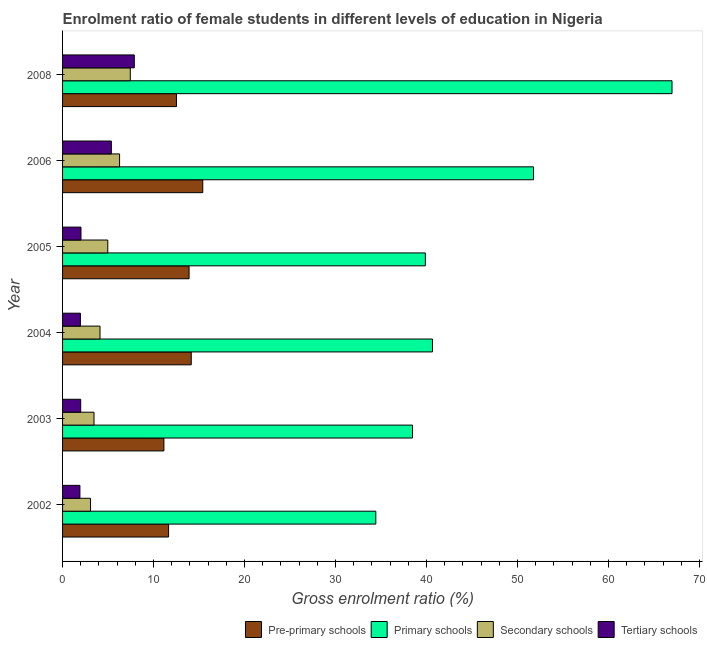Are the number of bars per tick equal to the number of legend labels?
Your response must be concise. Yes. Are the number of bars on each tick of the Y-axis equal?
Make the answer very short. Yes. How many bars are there on the 4th tick from the top?
Provide a short and direct response. 4. How many bars are there on the 6th tick from the bottom?
Ensure brevity in your answer.  4. In how many cases, is the number of bars for a given year not equal to the number of legend labels?
Your response must be concise. 0. What is the gross enrolment ratio(male) in secondary schools in 2005?
Your answer should be compact. 4.97. Across all years, what is the maximum gross enrolment ratio(male) in secondary schools?
Keep it short and to the point. 7.44. Across all years, what is the minimum gross enrolment ratio(male) in tertiary schools?
Your answer should be very brief. 1.91. In which year was the gross enrolment ratio(male) in primary schools minimum?
Give a very brief answer. 2002. What is the total gross enrolment ratio(male) in secondary schools in the graph?
Provide a succinct answer. 29.32. What is the difference between the gross enrolment ratio(male) in secondary schools in 2004 and that in 2006?
Ensure brevity in your answer.  -2.15. What is the difference between the gross enrolment ratio(male) in secondary schools in 2008 and the gross enrolment ratio(male) in primary schools in 2006?
Make the answer very short. -44.31. What is the average gross enrolment ratio(male) in tertiary schools per year?
Provide a succinct answer. 3.52. In the year 2004, what is the difference between the gross enrolment ratio(male) in primary schools and gross enrolment ratio(male) in pre-primary schools?
Offer a very short reply. 26.51. What is the ratio of the gross enrolment ratio(male) in secondary schools in 2003 to that in 2006?
Make the answer very short. 0.55. Is the gross enrolment ratio(male) in pre-primary schools in 2004 less than that in 2006?
Provide a succinct answer. Yes. What is the difference between the highest and the second highest gross enrolment ratio(male) in tertiary schools?
Your answer should be compact. 2.52. What is the difference between the highest and the lowest gross enrolment ratio(male) in secondary schools?
Make the answer very short. 4.37. What does the 3rd bar from the top in 2004 represents?
Your answer should be compact. Primary schools. What does the 2nd bar from the bottom in 2006 represents?
Give a very brief answer. Primary schools. How many bars are there?
Provide a succinct answer. 24. Are all the bars in the graph horizontal?
Keep it short and to the point. Yes. What is the difference between two consecutive major ticks on the X-axis?
Your response must be concise. 10. Are the values on the major ticks of X-axis written in scientific E-notation?
Your response must be concise. No. Does the graph contain grids?
Provide a succinct answer. No. Where does the legend appear in the graph?
Your answer should be compact. Bottom right. How many legend labels are there?
Provide a short and direct response. 4. What is the title of the graph?
Ensure brevity in your answer.  Enrolment ratio of female students in different levels of education in Nigeria. What is the label or title of the X-axis?
Your answer should be very brief. Gross enrolment ratio (%). What is the Gross enrolment ratio (%) of Pre-primary schools in 2002?
Offer a terse response. 11.65. What is the Gross enrolment ratio (%) of Primary schools in 2002?
Provide a succinct answer. 34.43. What is the Gross enrolment ratio (%) in Secondary schools in 2002?
Keep it short and to the point. 3.07. What is the Gross enrolment ratio (%) in Tertiary schools in 2002?
Provide a succinct answer. 1.91. What is the Gross enrolment ratio (%) of Pre-primary schools in 2003?
Your response must be concise. 11.14. What is the Gross enrolment ratio (%) of Primary schools in 2003?
Ensure brevity in your answer.  38.46. What is the Gross enrolment ratio (%) in Secondary schools in 2003?
Offer a very short reply. 3.46. What is the Gross enrolment ratio (%) in Tertiary schools in 2003?
Make the answer very short. 1.99. What is the Gross enrolment ratio (%) in Pre-primary schools in 2004?
Offer a terse response. 14.14. What is the Gross enrolment ratio (%) in Primary schools in 2004?
Keep it short and to the point. 40.65. What is the Gross enrolment ratio (%) of Secondary schools in 2004?
Your answer should be compact. 4.12. What is the Gross enrolment ratio (%) in Tertiary schools in 2004?
Your response must be concise. 1.96. What is the Gross enrolment ratio (%) in Pre-primary schools in 2005?
Ensure brevity in your answer.  13.9. What is the Gross enrolment ratio (%) in Primary schools in 2005?
Make the answer very short. 39.87. What is the Gross enrolment ratio (%) in Secondary schools in 2005?
Your response must be concise. 4.97. What is the Gross enrolment ratio (%) of Tertiary schools in 2005?
Provide a short and direct response. 2.02. What is the Gross enrolment ratio (%) in Pre-primary schools in 2006?
Give a very brief answer. 15.41. What is the Gross enrolment ratio (%) in Primary schools in 2006?
Ensure brevity in your answer.  51.76. What is the Gross enrolment ratio (%) in Secondary schools in 2006?
Keep it short and to the point. 6.27. What is the Gross enrolment ratio (%) in Tertiary schools in 2006?
Your response must be concise. 5.36. What is the Gross enrolment ratio (%) of Pre-primary schools in 2008?
Give a very brief answer. 12.52. What is the Gross enrolment ratio (%) in Primary schools in 2008?
Keep it short and to the point. 66.98. What is the Gross enrolment ratio (%) in Secondary schools in 2008?
Your response must be concise. 7.44. What is the Gross enrolment ratio (%) in Tertiary schools in 2008?
Provide a succinct answer. 7.88. Across all years, what is the maximum Gross enrolment ratio (%) of Pre-primary schools?
Offer a very short reply. 15.41. Across all years, what is the maximum Gross enrolment ratio (%) in Primary schools?
Give a very brief answer. 66.98. Across all years, what is the maximum Gross enrolment ratio (%) in Secondary schools?
Give a very brief answer. 7.44. Across all years, what is the maximum Gross enrolment ratio (%) in Tertiary schools?
Your response must be concise. 7.88. Across all years, what is the minimum Gross enrolment ratio (%) in Pre-primary schools?
Provide a short and direct response. 11.14. Across all years, what is the minimum Gross enrolment ratio (%) of Primary schools?
Offer a terse response. 34.43. Across all years, what is the minimum Gross enrolment ratio (%) in Secondary schools?
Provide a succinct answer. 3.07. Across all years, what is the minimum Gross enrolment ratio (%) of Tertiary schools?
Keep it short and to the point. 1.91. What is the total Gross enrolment ratio (%) of Pre-primary schools in the graph?
Make the answer very short. 78.76. What is the total Gross enrolment ratio (%) of Primary schools in the graph?
Your answer should be very brief. 272.14. What is the total Gross enrolment ratio (%) of Secondary schools in the graph?
Your answer should be very brief. 29.32. What is the total Gross enrolment ratio (%) of Tertiary schools in the graph?
Keep it short and to the point. 21.13. What is the difference between the Gross enrolment ratio (%) of Pre-primary schools in 2002 and that in 2003?
Give a very brief answer. 0.52. What is the difference between the Gross enrolment ratio (%) in Primary schools in 2002 and that in 2003?
Keep it short and to the point. -4.03. What is the difference between the Gross enrolment ratio (%) in Secondary schools in 2002 and that in 2003?
Your response must be concise. -0.38. What is the difference between the Gross enrolment ratio (%) of Tertiary schools in 2002 and that in 2003?
Give a very brief answer. -0.09. What is the difference between the Gross enrolment ratio (%) in Pre-primary schools in 2002 and that in 2004?
Offer a terse response. -2.49. What is the difference between the Gross enrolment ratio (%) of Primary schools in 2002 and that in 2004?
Offer a very short reply. -6.23. What is the difference between the Gross enrolment ratio (%) in Secondary schools in 2002 and that in 2004?
Your answer should be compact. -1.04. What is the difference between the Gross enrolment ratio (%) in Tertiary schools in 2002 and that in 2004?
Offer a terse response. -0.06. What is the difference between the Gross enrolment ratio (%) of Pre-primary schools in 2002 and that in 2005?
Your response must be concise. -2.25. What is the difference between the Gross enrolment ratio (%) of Primary schools in 2002 and that in 2005?
Your answer should be compact. -5.44. What is the difference between the Gross enrolment ratio (%) of Secondary schools in 2002 and that in 2005?
Make the answer very short. -1.89. What is the difference between the Gross enrolment ratio (%) of Tertiary schools in 2002 and that in 2005?
Provide a succinct answer. -0.12. What is the difference between the Gross enrolment ratio (%) of Pre-primary schools in 2002 and that in 2006?
Your response must be concise. -3.75. What is the difference between the Gross enrolment ratio (%) of Primary schools in 2002 and that in 2006?
Make the answer very short. -17.33. What is the difference between the Gross enrolment ratio (%) in Secondary schools in 2002 and that in 2006?
Your answer should be compact. -3.19. What is the difference between the Gross enrolment ratio (%) in Tertiary schools in 2002 and that in 2006?
Make the answer very short. -3.46. What is the difference between the Gross enrolment ratio (%) in Pre-primary schools in 2002 and that in 2008?
Your answer should be very brief. -0.87. What is the difference between the Gross enrolment ratio (%) of Primary schools in 2002 and that in 2008?
Offer a terse response. -32.55. What is the difference between the Gross enrolment ratio (%) of Secondary schools in 2002 and that in 2008?
Ensure brevity in your answer.  -4.37. What is the difference between the Gross enrolment ratio (%) in Tertiary schools in 2002 and that in 2008?
Ensure brevity in your answer.  -5.98. What is the difference between the Gross enrolment ratio (%) of Pre-primary schools in 2003 and that in 2004?
Offer a very short reply. -3.01. What is the difference between the Gross enrolment ratio (%) of Primary schools in 2003 and that in 2004?
Give a very brief answer. -2.19. What is the difference between the Gross enrolment ratio (%) in Secondary schools in 2003 and that in 2004?
Give a very brief answer. -0.66. What is the difference between the Gross enrolment ratio (%) in Tertiary schools in 2003 and that in 2004?
Keep it short and to the point. 0.03. What is the difference between the Gross enrolment ratio (%) of Pre-primary schools in 2003 and that in 2005?
Offer a very short reply. -2.77. What is the difference between the Gross enrolment ratio (%) of Primary schools in 2003 and that in 2005?
Your answer should be very brief. -1.41. What is the difference between the Gross enrolment ratio (%) of Secondary schools in 2003 and that in 2005?
Give a very brief answer. -1.51. What is the difference between the Gross enrolment ratio (%) of Tertiary schools in 2003 and that in 2005?
Your response must be concise. -0.03. What is the difference between the Gross enrolment ratio (%) in Pre-primary schools in 2003 and that in 2006?
Offer a terse response. -4.27. What is the difference between the Gross enrolment ratio (%) in Primary schools in 2003 and that in 2006?
Provide a short and direct response. -13.3. What is the difference between the Gross enrolment ratio (%) of Secondary schools in 2003 and that in 2006?
Offer a terse response. -2.81. What is the difference between the Gross enrolment ratio (%) in Tertiary schools in 2003 and that in 2006?
Offer a terse response. -3.37. What is the difference between the Gross enrolment ratio (%) in Pre-primary schools in 2003 and that in 2008?
Offer a very short reply. -1.38. What is the difference between the Gross enrolment ratio (%) in Primary schools in 2003 and that in 2008?
Offer a very short reply. -28.52. What is the difference between the Gross enrolment ratio (%) of Secondary schools in 2003 and that in 2008?
Offer a terse response. -3.99. What is the difference between the Gross enrolment ratio (%) of Tertiary schools in 2003 and that in 2008?
Provide a short and direct response. -5.89. What is the difference between the Gross enrolment ratio (%) of Pre-primary schools in 2004 and that in 2005?
Keep it short and to the point. 0.24. What is the difference between the Gross enrolment ratio (%) of Primary schools in 2004 and that in 2005?
Provide a succinct answer. 0.78. What is the difference between the Gross enrolment ratio (%) of Secondary schools in 2004 and that in 2005?
Provide a short and direct response. -0.85. What is the difference between the Gross enrolment ratio (%) of Tertiary schools in 2004 and that in 2005?
Keep it short and to the point. -0.06. What is the difference between the Gross enrolment ratio (%) in Pre-primary schools in 2004 and that in 2006?
Offer a very short reply. -1.27. What is the difference between the Gross enrolment ratio (%) of Primary schools in 2004 and that in 2006?
Keep it short and to the point. -11.1. What is the difference between the Gross enrolment ratio (%) in Secondary schools in 2004 and that in 2006?
Provide a short and direct response. -2.15. What is the difference between the Gross enrolment ratio (%) in Tertiary schools in 2004 and that in 2006?
Keep it short and to the point. -3.4. What is the difference between the Gross enrolment ratio (%) in Pre-primary schools in 2004 and that in 2008?
Ensure brevity in your answer.  1.62. What is the difference between the Gross enrolment ratio (%) of Primary schools in 2004 and that in 2008?
Provide a short and direct response. -26.33. What is the difference between the Gross enrolment ratio (%) in Secondary schools in 2004 and that in 2008?
Make the answer very short. -3.33. What is the difference between the Gross enrolment ratio (%) of Tertiary schools in 2004 and that in 2008?
Your response must be concise. -5.92. What is the difference between the Gross enrolment ratio (%) in Pre-primary schools in 2005 and that in 2006?
Ensure brevity in your answer.  -1.5. What is the difference between the Gross enrolment ratio (%) of Primary schools in 2005 and that in 2006?
Your response must be concise. -11.89. What is the difference between the Gross enrolment ratio (%) in Secondary schools in 2005 and that in 2006?
Offer a terse response. -1.3. What is the difference between the Gross enrolment ratio (%) in Tertiary schools in 2005 and that in 2006?
Give a very brief answer. -3.34. What is the difference between the Gross enrolment ratio (%) of Pre-primary schools in 2005 and that in 2008?
Ensure brevity in your answer.  1.39. What is the difference between the Gross enrolment ratio (%) in Primary schools in 2005 and that in 2008?
Provide a succinct answer. -27.11. What is the difference between the Gross enrolment ratio (%) in Secondary schools in 2005 and that in 2008?
Keep it short and to the point. -2.47. What is the difference between the Gross enrolment ratio (%) in Tertiary schools in 2005 and that in 2008?
Your answer should be compact. -5.86. What is the difference between the Gross enrolment ratio (%) of Pre-primary schools in 2006 and that in 2008?
Your answer should be compact. 2.89. What is the difference between the Gross enrolment ratio (%) in Primary schools in 2006 and that in 2008?
Your response must be concise. -15.22. What is the difference between the Gross enrolment ratio (%) of Secondary schools in 2006 and that in 2008?
Ensure brevity in your answer.  -1.18. What is the difference between the Gross enrolment ratio (%) in Tertiary schools in 2006 and that in 2008?
Give a very brief answer. -2.52. What is the difference between the Gross enrolment ratio (%) in Pre-primary schools in 2002 and the Gross enrolment ratio (%) in Primary schools in 2003?
Offer a terse response. -26.81. What is the difference between the Gross enrolment ratio (%) of Pre-primary schools in 2002 and the Gross enrolment ratio (%) of Secondary schools in 2003?
Your answer should be very brief. 8.2. What is the difference between the Gross enrolment ratio (%) in Pre-primary schools in 2002 and the Gross enrolment ratio (%) in Tertiary schools in 2003?
Offer a very short reply. 9.66. What is the difference between the Gross enrolment ratio (%) in Primary schools in 2002 and the Gross enrolment ratio (%) in Secondary schools in 2003?
Offer a terse response. 30.97. What is the difference between the Gross enrolment ratio (%) in Primary schools in 2002 and the Gross enrolment ratio (%) in Tertiary schools in 2003?
Offer a terse response. 32.43. What is the difference between the Gross enrolment ratio (%) of Secondary schools in 2002 and the Gross enrolment ratio (%) of Tertiary schools in 2003?
Your response must be concise. 1.08. What is the difference between the Gross enrolment ratio (%) of Pre-primary schools in 2002 and the Gross enrolment ratio (%) of Primary schools in 2004?
Give a very brief answer. -29. What is the difference between the Gross enrolment ratio (%) in Pre-primary schools in 2002 and the Gross enrolment ratio (%) in Secondary schools in 2004?
Offer a terse response. 7.54. What is the difference between the Gross enrolment ratio (%) in Pre-primary schools in 2002 and the Gross enrolment ratio (%) in Tertiary schools in 2004?
Provide a short and direct response. 9.69. What is the difference between the Gross enrolment ratio (%) of Primary schools in 2002 and the Gross enrolment ratio (%) of Secondary schools in 2004?
Give a very brief answer. 30.31. What is the difference between the Gross enrolment ratio (%) of Primary schools in 2002 and the Gross enrolment ratio (%) of Tertiary schools in 2004?
Offer a terse response. 32.46. What is the difference between the Gross enrolment ratio (%) in Secondary schools in 2002 and the Gross enrolment ratio (%) in Tertiary schools in 2004?
Give a very brief answer. 1.11. What is the difference between the Gross enrolment ratio (%) in Pre-primary schools in 2002 and the Gross enrolment ratio (%) in Primary schools in 2005?
Offer a very short reply. -28.22. What is the difference between the Gross enrolment ratio (%) in Pre-primary schools in 2002 and the Gross enrolment ratio (%) in Secondary schools in 2005?
Your answer should be very brief. 6.68. What is the difference between the Gross enrolment ratio (%) in Pre-primary schools in 2002 and the Gross enrolment ratio (%) in Tertiary schools in 2005?
Your answer should be very brief. 9.63. What is the difference between the Gross enrolment ratio (%) in Primary schools in 2002 and the Gross enrolment ratio (%) in Secondary schools in 2005?
Give a very brief answer. 29.46. What is the difference between the Gross enrolment ratio (%) of Primary schools in 2002 and the Gross enrolment ratio (%) of Tertiary schools in 2005?
Your response must be concise. 32.4. What is the difference between the Gross enrolment ratio (%) in Secondary schools in 2002 and the Gross enrolment ratio (%) in Tertiary schools in 2005?
Provide a short and direct response. 1.05. What is the difference between the Gross enrolment ratio (%) in Pre-primary schools in 2002 and the Gross enrolment ratio (%) in Primary schools in 2006?
Give a very brief answer. -40.1. What is the difference between the Gross enrolment ratio (%) of Pre-primary schools in 2002 and the Gross enrolment ratio (%) of Secondary schools in 2006?
Give a very brief answer. 5.39. What is the difference between the Gross enrolment ratio (%) in Pre-primary schools in 2002 and the Gross enrolment ratio (%) in Tertiary schools in 2006?
Give a very brief answer. 6.29. What is the difference between the Gross enrolment ratio (%) of Primary schools in 2002 and the Gross enrolment ratio (%) of Secondary schools in 2006?
Your answer should be very brief. 28.16. What is the difference between the Gross enrolment ratio (%) in Primary schools in 2002 and the Gross enrolment ratio (%) in Tertiary schools in 2006?
Ensure brevity in your answer.  29.06. What is the difference between the Gross enrolment ratio (%) of Secondary schools in 2002 and the Gross enrolment ratio (%) of Tertiary schools in 2006?
Ensure brevity in your answer.  -2.29. What is the difference between the Gross enrolment ratio (%) in Pre-primary schools in 2002 and the Gross enrolment ratio (%) in Primary schools in 2008?
Offer a terse response. -55.33. What is the difference between the Gross enrolment ratio (%) of Pre-primary schools in 2002 and the Gross enrolment ratio (%) of Secondary schools in 2008?
Your answer should be very brief. 4.21. What is the difference between the Gross enrolment ratio (%) in Pre-primary schools in 2002 and the Gross enrolment ratio (%) in Tertiary schools in 2008?
Your answer should be very brief. 3.77. What is the difference between the Gross enrolment ratio (%) in Primary schools in 2002 and the Gross enrolment ratio (%) in Secondary schools in 2008?
Offer a very short reply. 26.98. What is the difference between the Gross enrolment ratio (%) of Primary schools in 2002 and the Gross enrolment ratio (%) of Tertiary schools in 2008?
Your answer should be very brief. 26.54. What is the difference between the Gross enrolment ratio (%) of Secondary schools in 2002 and the Gross enrolment ratio (%) of Tertiary schools in 2008?
Make the answer very short. -4.81. What is the difference between the Gross enrolment ratio (%) of Pre-primary schools in 2003 and the Gross enrolment ratio (%) of Primary schools in 2004?
Make the answer very short. -29.52. What is the difference between the Gross enrolment ratio (%) of Pre-primary schools in 2003 and the Gross enrolment ratio (%) of Secondary schools in 2004?
Your response must be concise. 7.02. What is the difference between the Gross enrolment ratio (%) in Pre-primary schools in 2003 and the Gross enrolment ratio (%) in Tertiary schools in 2004?
Provide a short and direct response. 9.17. What is the difference between the Gross enrolment ratio (%) of Primary schools in 2003 and the Gross enrolment ratio (%) of Secondary schools in 2004?
Provide a short and direct response. 34.34. What is the difference between the Gross enrolment ratio (%) of Primary schools in 2003 and the Gross enrolment ratio (%) of Tertiary schools in 2004?
Your response must be concise. 36.5. What is the difference between the Gross enrolment ratio (%) in Secondary schools in 2003 and the Gross enrolment ratio (%) in Tertiary schools in 2004?
Make the answer very short. 1.49. What is the difference between the Gross enrolment ratio (%) in Pre-primary schools in 2003 and the Gross enrolment ratio (%) in Primary schools in 2005?
Keep it short and to the point. -28.73. What is the difference between the Gross enrolment ratio (%) in Pre-primary schools in 2003 and the Gross enrolment ratio (%) in Secondary schools in 2005?
Make the answer very short. 6.17. What is the difference between the Gross enrolment ratio (%) in Pre-primary schools in 2003 and the Gross enrolment ratio (%) in Tertiary schools in 2005?
Your answer should be very brief. 9.11. What is the difference between the Gross enrolment ratio (%) in Primary schools in 2003 and the Gross enrolment ratio (%) in Secondary schools in 2005?
Offer a terse response. 33.49. What is the difference between the Gross enrolment ratio (%) in Primary schools in 2003 and the Gross enrolment ratio (%) in Tertiary schools in 2005?
Your answer should be compact. 36.44. What is the difference between the Gross enrolment ratio (%) of Secondary schools in 2003 and the Gross enrolment ratio (%) of Tertiary schools in 2005?
Your answer should be compact. 1.43. What is the difference between the Gross enrolment ratio (%) in Pre-primary schools in 2003 and the Gross enrolment ratio (%) in Primary schools in 2006?
Keep it short and to the point. -40.62. What is the difference between the Gross enrolment ratio (%) in Pre-primary schools in 2003 and the Gross enrolment ratio (%) in Secondary schools in 2006?
Make the answer very short. 4.87. What is the difference between the Gross enrolment ratio (%) in Pre-primary schools in 2003 and the Gross enrolment ratio (%) in Tertiary schools in 2006?
Make the answer very short. 5.77. What is the difference between the Gross enrolment ratio (%) in Primary schools in 2003 and the Gross enrolment ratio (%) in Secondary schools in 2006?
Your answer should be compact. 32.19. What is the difference between the Gross enrolment ratio (%) in Primary schools in 2003 and the Gross enrolment ratio (%) in Tertiary schools in 2006?
Keep it short and to the point. 33.1. What is the difference between the Gross enrolment ratio (%) of Secondary schools in 2003 and the Gross enrolment ratio (%) of Tertiary schools in 2006?
Your answer should be compact. -1.91. What is the difference between the Gross enrolment ratio (%) in Pre-primary schools in 2003 and the Gross enrolment ratio (%) in Primary schools in 2008?
Offer a very short reply. -55.84. What is the difference between the Gross enrolment ratio (%) in Pre-primary schools in 2003 and the Gross enrolment ratio (%) in Secondary schools in 2008?
Make the answer very short. 3.69. What is the difference between the Gross enrolment ratio (%) in Pre-primary schools in 2003 and the Gross enrolment ratio (%) in Tertiary schools in 2008?
Give a very brief answer. 3.25. What is the difference between the Gross enrolment ratio (%) of Primary schools in 2003 and the Gross enrolment ratio (%) of Secondary schools in 2008?
Keep it short and to the point. 31.02. What is the difference between the Gross enrolment ratio (%) in Primary schools in 2003 and the Gross enrolment ratio (%) in Tertiary schools in 2008?
Your answer should be very brief. 30.58. What is the difference between the Gross enrolment ratio (%) in Secondary schools in 2003 and the Gross enrolment ratio (%) in Tertiary schools in 2008?
Make the answer very short. -4.43. What is the difference between the Gross enrolment ratio (%) of Pre-primary schools in 2004 and the Gross enrolment ratio (%) of Primary schools in 2005?
Your response must be concise. -25.73. What is the difference between the Gross enrolment ratio (%) of Pre-primary schools in 2004 and the Gross enrolment ratio (%) of Secondary schools in 2005?
Provide a succinct answer. 9.17. What is the difference between the Gross enrolment ratio (%) of Pre-primary schools in 2004 and the Gross enrolment ratio (%) of Tertiary schools in 2005?
Offer a very short reply. 12.12. What is the difference between the Gross enrolment ratio (%) in Primary schools in 2004 and the Gross enrolment ratio (%) in Secondary schools in 2005?
Offer a terse response. 35.68. What is the difference between the Gross enrolment ratio (%) of Primary schools in 2004 and the Gross enrolment ratio (%) of Tertiary schools in 2005?
Offer a terse response. 38.63. What is the difference between the Gross enrolment ratio (%) of Secondary schools in 2004 and the Gross enrolment ratio (%) of Tertiary schools in 2005?
Your answer should be very brief. 2.09. What is the difference between the Gross enrolment ratio (%) of Pre-primary schools in 2004 and the Gross enrolment ratio (%) of Primary schools in 2006?
Your answer should be compact. -37.62. What is the difference between the Gross enrolment ratio (%) of Pre-primary schools in 2004 and the Gross enrolment ratio (%) of Secondary schools in 2006?
Offer a very short reply. 7.88. What is the difference between the Gross enrolment ratio (%) of Pre-primary schools in 2004 and the Gross enrolment ratio (%) of Tertiary schools in 2006?
Make the answer very short. 8.78. What is the difference between the Gross enrolment ratio (%) of Primary schools in 2004 and the Gross enrolment ratio (%) of Secondary schools in 2006?
Ensure brevity in your answer.  34.39. What is the difference between the Gross enrolment ratio (%) in Primary schools in 2004 and the Gross enrolment ratio (%) in Tertiary schools in 2006?
Your answer should be very brief. 35.29. What is the difference between the Gross enrolment ratio (%) of Secondary schools in 2004 and the Gross enrolment ratio (%) of Tertiary schools in 2006?
Your answer should be compact. -1.25. What is the difference between the Gross enrolment ratio (%) of Pre-primary schools in 2004 and the Gross enrolment ratio (%) of Primary schools in 2008?
Offer a very short reply. -52.84. What is the difference between the Gross enrolment ratio (%) of Pre-primary schools in 2004 and the Gross enrolment ratio (%) of Secondary schools in 2008?
Ensure brevity in your answer.  6.7. What is the difference between the Gross enrolment ratio (%) in Pre-primary schools in 2004 and the Gross enrolment ratio (%) in Tertiary schools in 2008?
Keep it short and to the point. 6.26. What is the difference between the Gross enrolment ratio (%) in Primary schools in 2004 and the Gross enrolment ratio (%) in Secondary schools in 2008?
Your response must be concise. 33.21. What is the difference between the Gross enrolment ratio (%) in Primary schools in 2004 and the Gross enrolment ratio (%) in Tertiary schools in 2008?
Offer a terse response. 32.77. What is the difference between the Gross enrolment ratio (%) of Secondary schools in 2004 and the Gross enrolment ratio (%) of Tertiary schools in 2008?
Your answer should be very brief. -3.77. What is the difference between the Gross enrolment ratio (%) of Pre-primary schools in 2005 and the Gross enrolment ratio (%) of Primary schools in 2006?
Make the answer very short. -37.85. What is the difference between the Gross enrolment ratio (%) in Pre-primary schools in 2005 and the Gross enrolment ratio (%) in Secondary schools in 2006?
Provide a succinct answer. 7.64. What is the difference between the Gross enrolment ratio (%) of Pre-primary schools in 2005 and the Gross enrolment ratio (%) of Tertiary schools in 2006?
Make the answer very short. 8.54. What is the difference between the Gross enrolment ratio (%) in Primary schools in 2005 and the Gross enrolment ratio (%) in Secondary schools in 2006?
Provide a succinct answer. 33.6. What is the difference between the Gross enrolment ratio (%) of Primary schools in 2005 and the Gross enrolment ratio (%) of Tertiary schools in 2006?
Offer a terse response. 34.51. What is the difference between the Gross enrolment ratio (%) of Secondary schools in 2005 and the Gross enrolment ratio (%) of Tertiary schools in 2006?
Your response must be concise. -0.39. What is the difference between the Gross enrolment ratio (%) in Pre-primary schools in 2005 and the Gross enrolment ratio (%) in Primary schools in 2008?
Give a very brief answer. -53.07. What is the difference between the Gross enrolment ratio (%) in Pre-primary schools in 2005 and the Gross enrolment ratio (%) in Secondary schools in 2008?
Your response must be concise. 6.46. What is the difference between the Gross enrolment ratio (%) in Pre-primary schools in 2005 and the Gross enrolment ratio (%) in Tertiary schools in 2008?
Your answer should be very brief. 6.02. What is the difference between the Gross enrolment ratio (%) in Primary schools in 2005 and the Gross enrolment ratio (%) in Secondary schools in 2008?
Give a very brief answer. 32.43. What is the difference between the Gross enrolment ratio (%) of Primary schools in 2005 and the Gross enrolment ratio (%) of Tertiary schools in 2008?
Make the answer very short. 31.99. What is the difference between the Gross enrolment ratio (%) in Secondary schools in 2005 and the Gross enrolment ratio (%) in Tertiary schools in 2008?
Your answer should be very brief. -2.91. What is the difference between the Gross enrolment ratio (%) of Pre-primary schools in 2006 and the Gross enrolment ratio (%) of Primary schools in 2008?
Your answer should be compact. -51.57. What is the difference between the Gross enrolment ratio (%) of Pre-primary schools in 2006 and the Gross enrolment ratio (%) of Secondary schools in 2008?
Provide a succinct answer. 7.97. What is the difference between the Gross enrolment ratio (%) in Pre-primary schools in 2006 and the Gross enrolment ratio (%) in Tertiary schools in 2008?
Your answer should be very brief. 7.52. What is the difference between the Gross enrolment ratio (%) of Primary schools in 2006 and the Gross enrolment ratio (%) of Secondary schools in 2008?
Your answer should be very brief. 44.31. What is the difference between the Gross enrolment ratio (%) of Primary schools in 2006 and the Gross enrolment ratio (%) of Tertiary schools in 2008?
Keep it short and to the point. 43.87. What is the difference between the Gross enrolment ratio (%) of Secondary schools in 2006 and the Gross enrolment ratio (%) of Tertiary schools in 2008?
Ensure brevity in your answer.  -1.62. What is the average Gross enrolment ratio (%) of Pre-primary schools per year?
Give a very brief answer. 13.13. What is the average Gross enrolment ratio (%) of Primary schools per year?
Offer a terse response. 45.36. What is the average Gross enrolment ratio (%) in Secondary schools per year?
Keep it short and to the point. 4.89. What is the average Gross enrolment ratio (%) in Tertiary schools per year?
Your answer should be very brief. 3.52. In the year 2002, what is the difference between the Gross enrolment ratio (%) in Pre-primary schools and Gross enrolment ratio (%) in Primary schools?
Your answer should be compact. -22.77. In the year 2002, what is the difference between the Gross enrolment ratio (%) in Pre-primary schools and Gross enrolment ratio (%) in Secondary schools?
Make the answer very short. 8.58. In the year 2002, what is the difference between the Gross enrolment ratio (%) in Pre-primary schools and Gross enrolment ratio (%) in Tertiary schools?
Provide a short and direct response. 9.75. In the year 2002, what is the difference between the Gross enrolment ratio (%) in Primary schools and Gross enrolment ratio (%) in Secondary schools?
Offer a very short reply. 31.35. In the year 2002, what is the difference between the Gross enrolment ratio (%) of Primary schools and Gross enrolment ratio (%) of Tertiary schools?
Offer a very short reply. 32.52. In the year 2002, what is the difference between the Gross enrolment ratio (%) of Secondary schools and Gross enrolment ratio (%) of Tertiary schools?
Make the answer very short. 1.17. In the year 2003, what is the difference between the Gross enrolment ratio (%) of Pre-primary schools and Gross enrolment ratio (%) of Primary schools?
Offer a terse response. -27.32. In the year 2003, what is the difference between the Gross enrolment ratio (%) in Pre-primary schools and Gross enrolment ratio (%) in Secondary schools?
Provide a succinct answer. 7.68. In the year 2003, what is the difference between the Gross enrolment ratio (%) of Pre-primary schools and Gross enrolment ratio (%) of Tertiary schools?
Your response must be concise. 9.14. In the year 2003, what is the difference between the Gross enrolment ratio (%) in Primary schools and Gross enrolment ratio (%) in Secondary schools?
Offer a terse response. 35. In the year 2003, what is the difference between the Gross enrolment ratio (%) in Primary schools and Gross enrolment ratio (%) in Tertiary schools?
Your response must be concise. 36.47. In the year 2003, what is the difference between the Gross enrolment ratio (%) in Secondary schools and Gross enrolment ratio (%) in Tertiary schools?
Give a very brief answer. 1.46. In the year 2004, what is the difference between the Gross enrolment ratio (%) of Pre-primary schools and Gross enrolment ratio (%) of Primary schools?
Provide a short and direct response. -26.51. In the year 2004, what is the difference between the Gross enrolment ratio (%) of Pre-primary schools and Gross enrolment ratio (%) of Secondary schools?
Give a very brief answer. 10.03. In the year 2004, what is the difference between the Gross enrolment ratio (%) in Pre-primary schools and Gross enrolment ratio (%) in Tertiary schools?
Offer a terse response. 12.18. In the year 2004, what is the difference between the Gross enrolment ratio (%) in Primary schools and Gross enrolment ratio (%) in Secondary schools?
Offer a very short reply. 36.54. In the year 2004, what is the difference between the Gross enrolment ratio (%) of Primary schools and Gross enrolment ratio (%) of Tertiary schools?
Provide a short and direct response. 38.69. In the year 2004, what is the difference between the Gross enrolment ratio (%) in Secondary schools and Gross enrolment ratio (%) in Tertiary schools?
Your response must be concise. 2.15. In the year 2005, what is the difference between the Gross enrolment ratio (%) in Pre-primary schools and Gross enrolment ratio (%) in Primary schools?
Your answer should be very brief. -25.97. In the year 2005, what is the difference between the Gross enrolment ratio (%) of Pre-primary schools and Gross enrolment ratio (%) of Secondary schools?
Offer a terse response. 8.93. In the year 2005, what is the difference between the Gross enrolment ratio (%) in Pre-primary schools and Gross enrolment ratio (%) in Tertiary schools?
Provide a succinct answer. 11.88. In the year 2005, what is the difference between the Gross enrolment ratio (%) of Primary schools and Gross enrolment ratio (%) of Secondary schools?
Provide a short and direct response. 34.9. In the year 2005, what is the difference between the Gross enrolment ratio (%) in Primary schools and Gross enrolment ratio (%) in Tertiary schools?
Provide a short and direct response. 37.85. In the year 2005, what is the difference between the Gross enrolment ratio (%) of Secondary schools and Gross enrolment ratio (%) of Tertiary schools?
Your response must be concise. 2.94. In the year 2006, what is the difference between the Gross enrolment ratio (%) in Pre-primary schools and Gross enrolment ratio (%) in Primary schools?
Your answer should be very brief. -36.35. In the year 2006, what is the difference between the Gross enrolment ratio (%) of Pre-primary schools and Gross enrolment ratio (%) of Secondary schools?
Your answer should be compact. 9.14. In the year 2006, what is the difference between the Gross enrolment ratio (%) of Pre-primary schools and Gross enrolment ratio (%) of Tertiary schools?
Ensure brevity in your answer.  10.05. In the year 2006, what is the difference between the Gross enrolment ratio (%) of Primary schools and Gross enrolment ratio (%) of Secondary schools?
Ensure brevity in your answer.  45.49. In the year 2006, what is the difference between the Gross enrolment ratio (%) of Primary schools and Gross enrolment ratio (%) of Tertiary schools?
Make the answer very short. 46.39. In the year 2006, what is the difference between the Gross enrolment ratio (%) in Secondary schools and Gross enrolment ratio (%) in Tertiary schools?
Offer a terse response. 0.9. In the year 2008, what is the difference between the Gross enrolment ratio (%) in Pre-primary schools and Gross enrolment ratio (%) in Primary schools?
Your answer should be compact. -54.46. In the year 2008, what is the difference between the Gross enrolment ratio (%) of Pre-primary schools and Gross enrolment ratio (%) of Secondary schools?
Your answer should be compact. 5.08. In the year 2008, what is the difference between the Gross enrolment ratio (%) of Pre-primary schools and Gross enrolment ratio (%) of Tertiary schools?
Make the answer very short. 4.63. In the year 2008, what is the difference between the Gross enrolment ratio (%) in Primary schools and Gross enrolment ratio (%) in Secondary schools?
Your answer should be compact. 59.54. In the year 2008, what is the difference between the Gross enrolment ratio (%) in Primary schools and Gross enrolment ratio (%) in Tertiary schools?
Your answer should be compact. 59.09. In the year 2008, what is the difference between the Gross enrolment ratio (%) in Secondary schools and Gross enrolment ratio (%) in Tertiary schools?
Ensure brevity in your answer.  -0.44. What is the ratio of the Gross enrolment ratio (%) in Pre-primary schools in 2002 to that in 2003?
Offer a terse response. 1.05. What is the ratio of the Gross enrolment ratio (%) of Primary schools in 2002 to that in 2003?
Your response must be concise. 0.9. What is the ratio of the Gross enrolment ratio (%) in Secondary schools in 2002 to that in 2003?
Make the answer very short. 0.89. What is the ratio of the Gross enrolment ratio (%) of Tertiary schools in 2002 to that in 2003?
Provide a succinct answer. 0.96. What is the ratio of the Gross enrolment ratio (%) of Pre-primary schools in 2002 to that in 2004?
Give a very brief answer. 0.82. What is the ratio of the Gross enrolment ratio (%) in Primary schools in 2002 to that in 2004?
Offer a very short reply. 0.85. What is the ratio of the Gross enrolment ratio (%) of Secondary schools in 2002 to that in 2004?
Your answer should be very brief. 0.75. What is the ratio of the Gross enrolment ratio (%) in Tertiary schools in 2002 to that in 2004?
Make the answer very short. 0.97. What is the ratio of the Gross enrolment ratio (%) in Pre-primary schools in 2002 to that in 2005?
Provide a short and direct response. 0.84. What is the ratio of the Gross enrolment ratio (%) of Primary schools in 2002 to that in 2005?
Keep it short and to the point. 0.86. What is the ratio of the Gross enrolment ratio (%) of Secondary schools in 2002 to that in 2005?
Give a very brief answer. 0.62. What is the ratio of the Gross enrolment ratio (%) in Tertiary schools in 2002 to that in 2005?
Your answer should be compact. 0.94. What is the ratio of the Gross enrolment ratio (%) of Pre-primary schools in 2002 to that in 2006?
Provide a short and direct response. 0.76. What is the ratio of the Gross enrolment ratio (%) in Primary schools in 2002 to that in 2006?
Your answer should be compact. 0.67. What is the ratio of the Gross enrolment ratio (%) of Secondary schools in 2002 to that in 2006?
Provide a short and direct response. 0.49. What is the ratio of the Gross enrolment ratio (%) in Tertiary schools in 2002 to that in 2006?
Your answer should be compact. 0.36. What is the ratio of the Gross enrolment ratio (%) in Pre-primary schools in 2002 to that in 2008?
Your answer should be compact. 0.93. What is the ratio of the Gross enrolment ratio (%) of Primary schools in 2002 to that in 2008?
Give a very brief answer. 0.51. What is the ratio of the Gross enrolment ratio (%) of Secondary schools in 2002 to that in 2008?
Your answer should be very brief. 0.41. What is the ratio of the Gross enrolment ratio (%) in Tertiary schools in 2002 to that in 2008?
Keep it short and to the point. 0.24. What is the ratio of the Gross enrolment ratio (%) of Pre-primary schools in 2003 to that in 2004?
Your answer should be compact. 0.79. What is the ratio of the Gross enrolment ratio (%) of Primary schools in 2003 to that in 2004?
Your answer should be very brief. 0.95. What is the ratio of the Gross enrolment ratio (%) in Secondary schools in 2003 to that in 2004?
Provide a succinct answer. 0.84. What is the ratio of the Gross enrolment ratio (%) of Tertiary schools in 2003 to that in 2004?
Your answer should be very brief. 1.02. What is the ratio of the Gross enrolment ratio (%) in Pre-primary schools in 2003 to that in 2005?
Your response must be concise. 0.8. What is the ratio of the Gross enrolment ratio (%) in Primary schools in 2003 to that in 2005?
Provide a short and direct response. 0.96. What is the ratio of the Gross enrolment ratio (%) in Secondary schools in 2003 to that in 2005?
Your answer should be compact. 0.7. What is the ratio of the Gross enrolment ratio (%) in Tertiary schools in 2003 to that in 2005?
Make the answer very short. 0.98. What is the ratio of the Gross enrolment ratio (%) in Pre-primary schools in 2003 to that in 2006?
Provide a succinct answer. 0.72. What is the ratio of the Gross enrolment ratio (%) of Primary schools in 2003 to that in 2006?
Make the answer very short. 0.74. What is the ratio of the Gross enrolment ratio (%) in Secondary schools in 2003 to that in 2006?
Ensure brevity in your answer.  0.55. What is the ratio of the Gross enrolment ratio (%) of Tertiary schools in 2003 to that in 2006?
Offer a very short reply. 0.37. What is the ratio of the Gross enrolment ratio (%) of Pre-primary schools in 2003 to that in 2008?
Ensure brevity in your answer.  0.89. What is the ratio of the Gross enrolment ratio (%) of Primary schools in 2003 to that in 2008?
Keep it short and to the point. 0.57. What is the ratio of the Gross enrolment ratio (%) of Secondary schools in 2003 to that in 2008?
Offer a very short reply. 0.46. What is the ratio of the Gross enrolment ratio (%) in Tertiary schools in 2003 to that in 2008?
Offer a very short reply. 0.25. What is the ratio of the Gross enrolment ratio (%) in Pre-primary schools in 2004 to that in 2005?
Offer a very short reply. 1.02. What is the ratio of the Gross enrolment ratio (%) in Primary schools in 2004 to that in 2005?
Give a very brief answer. 1.02. What is the ratio of the Gross enrolment ratio (%) of Secondary schools in 2004 to that in 2005?
Ensure brevity in your answer.  0.83. What is the ratio of the Gross enrolment ratio (%) of Tertiary schools in 2004 to that in 2005?
Offer a very short reply. 0.97. What is the ratio of the Gross enrolment ratio (%) in Pre-primary schools in 2004 to that in 2006?
Provide a short and direct response. 0.92. What is the ratio of the Gross enrolment ratio (%) of Primary schools in 2004 to that in 2006?
Offer a very short reply. 0.79. What is the ratio of the Gross enrolment ratio (%) of Secondary schools in 2004 to that in 2006?
Offer a terse response. 0.66. What is the ratio of the Gross enrolment ratio (%) of Tertiary schools in 2004 to that in 2006?
Your response must be concise. 0.37. What is the ratio of the Gross enrolment ratio (%) in Pre-primary schools in 2004 to that in 2008?
Ensure brevity in your answer.  1.13. What is the ratio of the Gross enrolment ratio (%) of Primary schools in 2004 to that in 2008?
Offer a very short reply. 0.61. What is the ratio of the Gross enrolment ratio (%) of Secondary schools in 2004 to that in 2008?
Ensure brevity in your answer.  0.55. What is the ratio of the Gross enrolment ratio (%) in Tertiary schools in 2004 to that in 2008?
Your answer should be compact. 0.25. What is the ratio of the Gross enrolment ratio (%) of Pre-primary schools in 2005 to that in 2006?
Provide a succinct answer. 0.9. What is the ratio of the Gross enrolment ratio (%) of Primary schools in 2005 to that in 2006?
Provide a short and direct response. 0.77. What is the ratio of the Gross enrolment ratio (%) in Secondary schools in 2005 to that in 2006?
Your response must be concise. 0.79. What is the ratio of the Gross enrolment ratio (%) in Tertiary schools in 2005 to that in 2006?
Give a very brief answer. 0.38. What is the ratio of the Gross enrolment ratio (%) of Pre-primary schools in 2005 to that in 2008?
Make the answer very short. 1.11. What is the ratio of the Gross enrolment ratio (%) of Primary schools in 2005 to that in 2008?
Offer a very short reply. 0.6. What is the ratio of the Gross enrolment ratio (%) of Secondary schools in 2005 to that in 2008?
Your answer should be compact. 0.67. What is the ratio of the Gross enrolment ratio (%) of Tertiary schools in 2005 to that in 2008?
Provide a short and direct response. 0.26. What is the ratio of the Gross enrolment ratio (%) in Pre-primary schools in 2006 to that in 2008?
Your response must be concise. 1.23. What is the ratio of the Gross enrolment ratio (%) in Primary schools in 2006 to that in 2008?
Provide a short and direct response. 0.77. What is the ratio of the Gross enrolment ratio (%) of Secondary schools in 2006 to that in 2008?
Your answer should be very brief. 0.84. What is the ratio of the Gross enrolment ratio (%) of Tertiary schools in 2006 to that in 2008?
Provide a short and direct response. 0.68. What is the difference between the highest and the second highest Gross enrolment ratio (%) in Pre-primary schools?
Ensure brevity in your answer.  1.27. What is the difference between the highest and the second highest Gross enrolment ratio (%) in Primary schools?
Your answer should be very brief. 15.22. What is the difference between the highest and the second highest Gross enrolment ratio (%) in Secondary schools?
Ensure brevity in your answer.  1.18. What is the difference between the highest and the second highest Gross enrolment ratio (%) in Tertiary schools?
Your answer should be compact. 2.52. What is the difference between the highest and the lowest Gross enrolment ratio (%) of Pre-primary schools?
Your response must be concise. 4.27. What is the difference between the highest and the lowest Gross enrolment ratio (%) of Primary schools?
Your response must be concise. 32.55. What is the difference between the highest and the lowest Gross enrolment ratio (%) in Secondary schools?
Give a very brief answer. 4.37. What is the difference between the highest and the lowest Gross enrolment ratio (%) in Tertiary schools?
Your answer should be very brief. 5.98. 